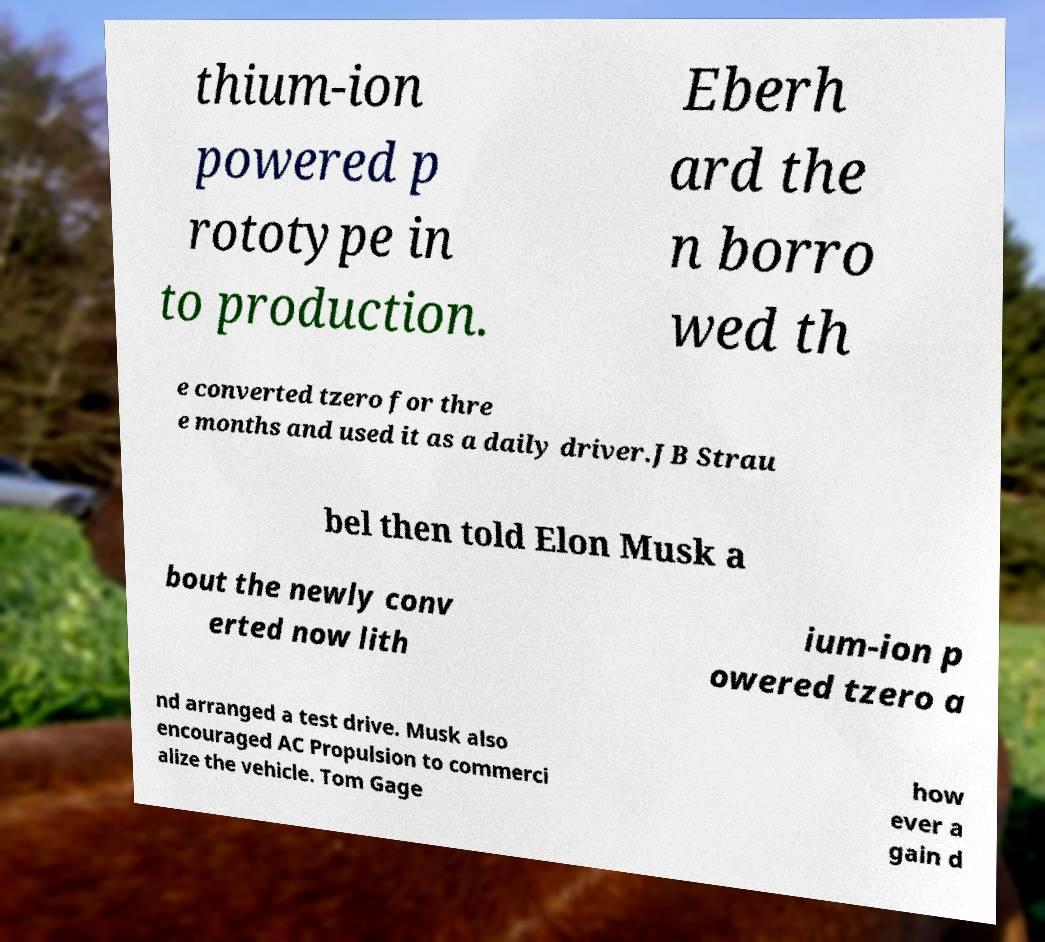I need the written content from this picture converted into text. Can you do that? thium-ion powered p rototype in to production. Eberh ard the n borro wed th e converted tzero for thre e months and used it as a daily driver.JB Strau bel then told Elon Musk a bout the newly conv erted now lith ium-ion p owered tzero a nd arranged a test drive. Musk also encouraged AC Propulsion to commerci alize the vehicle. Tom Gage how ever a gain d 